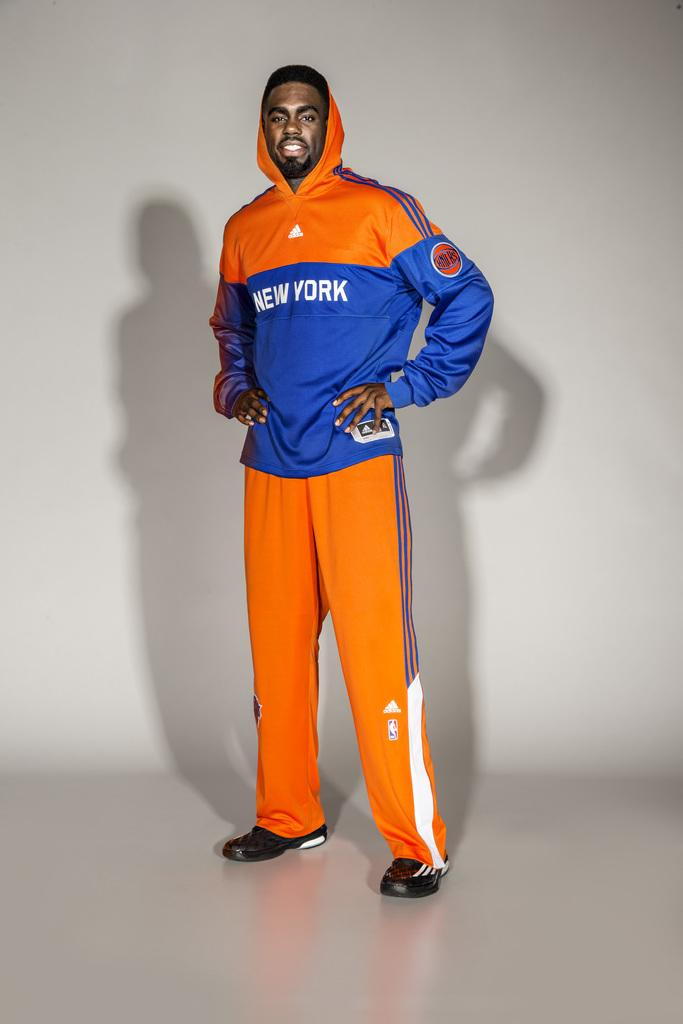Provide a one-sentence caption for the provided image. An African American male standing in a orange and blue New york sweat suit. 